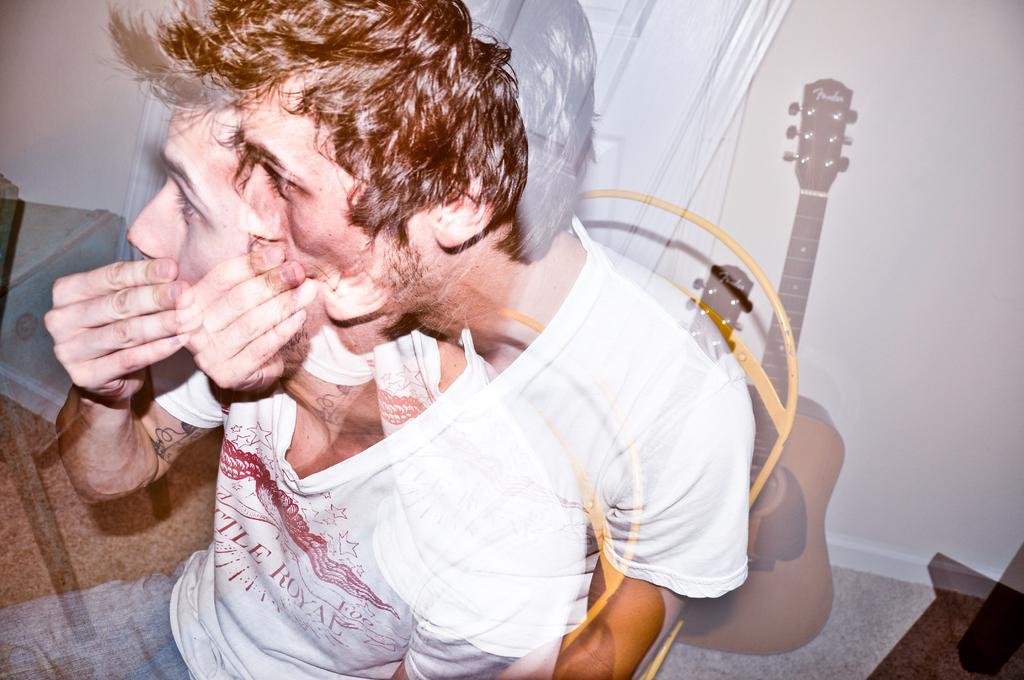In one or two sentences, can you explain what this image depicts? In this picture we can see a man is sitting on a chair, on the right side there is a guitar, we can see a wall and a door in the background. 